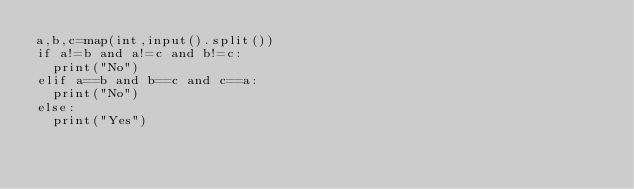Convert code to text. <code><loc_0><loc_0><loc_500><loc_500><_Python_>a,b,c=map(int,input().split())
if a!=b and a!=c and b!=c:
  print("No")
elif a==b and b==c and c==a:
  print("No")
else:
  print("Yes")</code> 